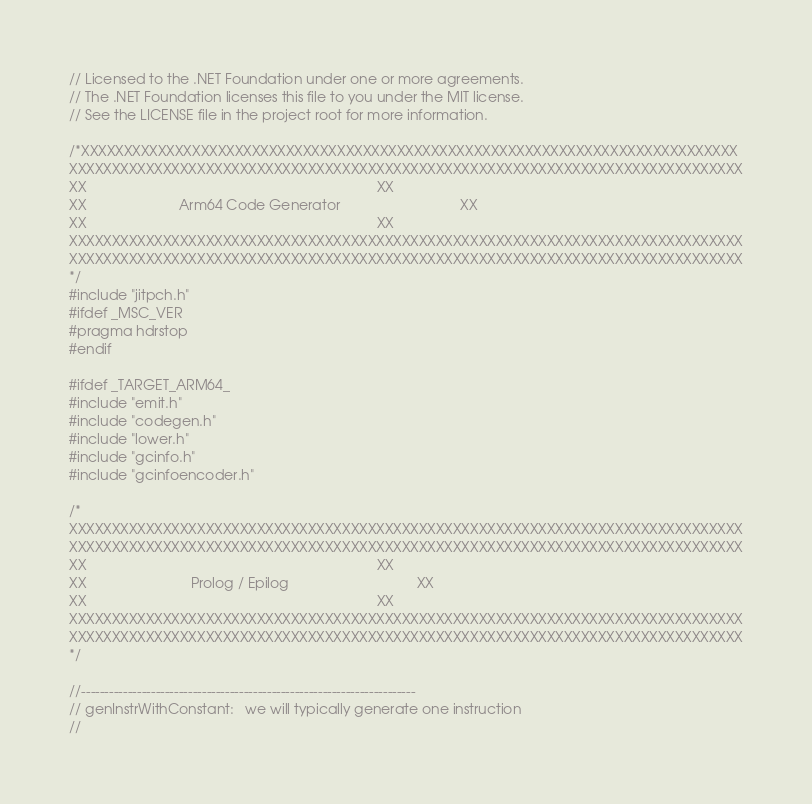Convert code to text. <code><loc_0><loc_0><loc_500><loc_500><_C++_>// Licensed to the .NET Foundation under one or more agreements.
// The .NET Foundation licenses this file to you under the MIT license.
// See the LICENSE file in the project root for more information.

/*XXXXXXXXXXXXXXXXXXXXXXXXXXXXXXXXXXXXXXXXXXXXXXXXXXXXXXXXXXXXXXXXXXXXXXXXXXXXX
XXXXXXXXXXXXXXXXXXXXXXXXXXXXXXXXXXXXXXXXXXXXXXXXXXXXXXXXXXXXXXXXXXXXXXXXXXXXXXX
XX                                                                           XX
XX                        Arm64 Code Generator                               XX
XX                                                                           XX
XXXXXXXXXXXXXXXXXXXXXXXXXXXXXXXXXXXXXXXXXXXXXXXXXXXXXXXXXXXXXXXXXXXXXXXXXXXXXXX
XXXXXXXXXXXXXXXXXXXXXXXXXXXXXXXXXXXXXXXXXXXXXXXXXXXXXXXXXXXXXXXXXXXXXXXXXXXXXXX
*/
#include "jitpch.h"
#ifdef _MSC_VER
#pragma hdrstop
#endif

#ifdef _TARGET_ARM64_
#include "emit.h"
#include "codegen.h"
#include "lower.h"
#include "gcinfo.h"
#include "gcinfoencoder.h"

/*
XXXXXXXXXXXXXXXXXXXXXXXXXXXXXXXXXXXXXXXXXXXXXXXXXXXXXXXXXXXXXXXXXXXXXXXXXXXXXXX
XXXXXXXXXXXXXXXXXXXXXXXXXXXXXXXXXXXXXXXXXXXXXXXXXXXXXXXXXXXXXXXXXXXXXXXXXXXXXXX
XX                                                                           XX
XX                           Prolog / Epilog                                 XX
XX                                                                           XX
XXXXXXXXXXXXXXXXXXXXXXXXXXXXXXXXXXXXXXXXXXXXXXXXXXXXXXXXXXXXXXXXXXXXXXXXXXXXXXX
XXXXXXXXXXXXXXXXXXXXXXXXXXXXXXXXXXXXXXXXXXXXXXXXXXXXXXXXXXXXXXXXXXXXXXXXXXXXXXX
*/

//------------------------------------------------------------------------
// genInstrWithConstant:   we will typically generate one instruction
//</code> 